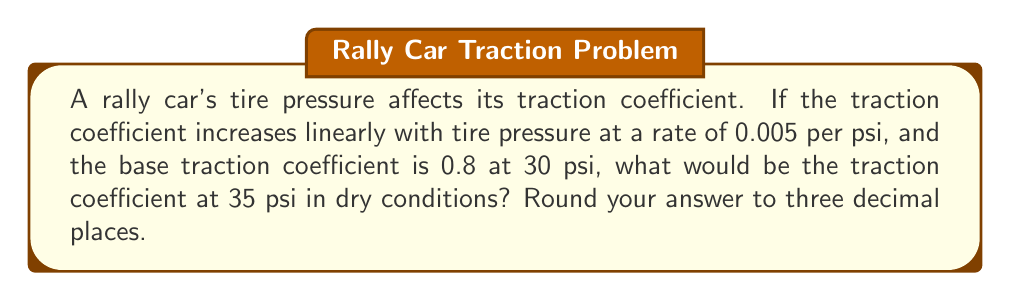Could you help me with this problem? Let's approach this step-by-step:

1) We're given that the traction coefficient increases linearly with tire pressure.

2) The rate of increase is 0.005 per psi.

3) At 30 psi, the base traction coefficient is 0.8.

4) We need to find the traction coefficient at 35 psi.

5) Let's define our variables:
   $x$ = tire pressure in psi
   $y$ = traction coefficient

6) We can write the linear equation:
   $y = mx + b$
   Where $m$ is the slope (rate of increase) and $b$ is the y-intercept.

7) We know one point (30, 0.8) and the slope (0.005). Let's find $b$:
   $0.8 = 0.005(30) + b$
   $0.8 = 0.15 + b$
   $b = 0.65$

8) So our equation is:
   $y = 0.005x + 0.65$

9) Now, let's calculate the traction coefficient at 35 psi:
   $y = 0.005(35) + 0.65$
   $y = 0.175 + 0.65$
   $y = 0.825$

10) Rounding to three decimal places: 0.825
Answer: 0.825 